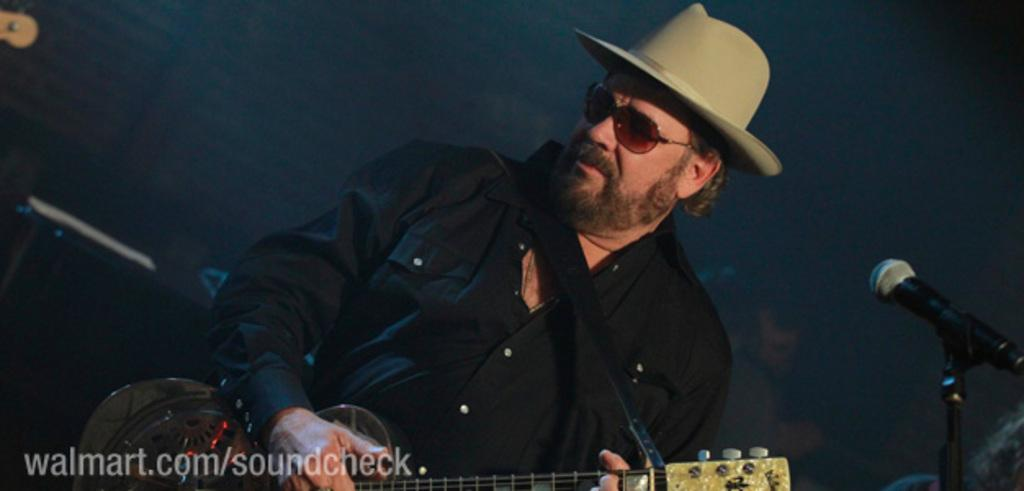What is the main subject of the image? The main subject of the image is a man. What is the man wearing on his head? The man is wearing a hat. What is the man wearing to protect his eyes? The man is wearing goggles. What is the man doing in the image? The man is playing the guitar. What might the man be using to amplify his voice? There is a microphone in front of the man. What type of glue is the man using to design the hospital in the image? There is no glue, design, or hospital present in the image; it features a man playing the guitar with a hat and goggles. 